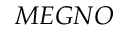<formula> <loc_0><loc_0><loc_500><loc_500>M E G N O</formula> 